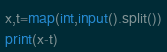<code> <loc_0><loc_0><loc_500><loc_500><_Python_>x,t=map(int,input().split())
print(x-t)</code> 